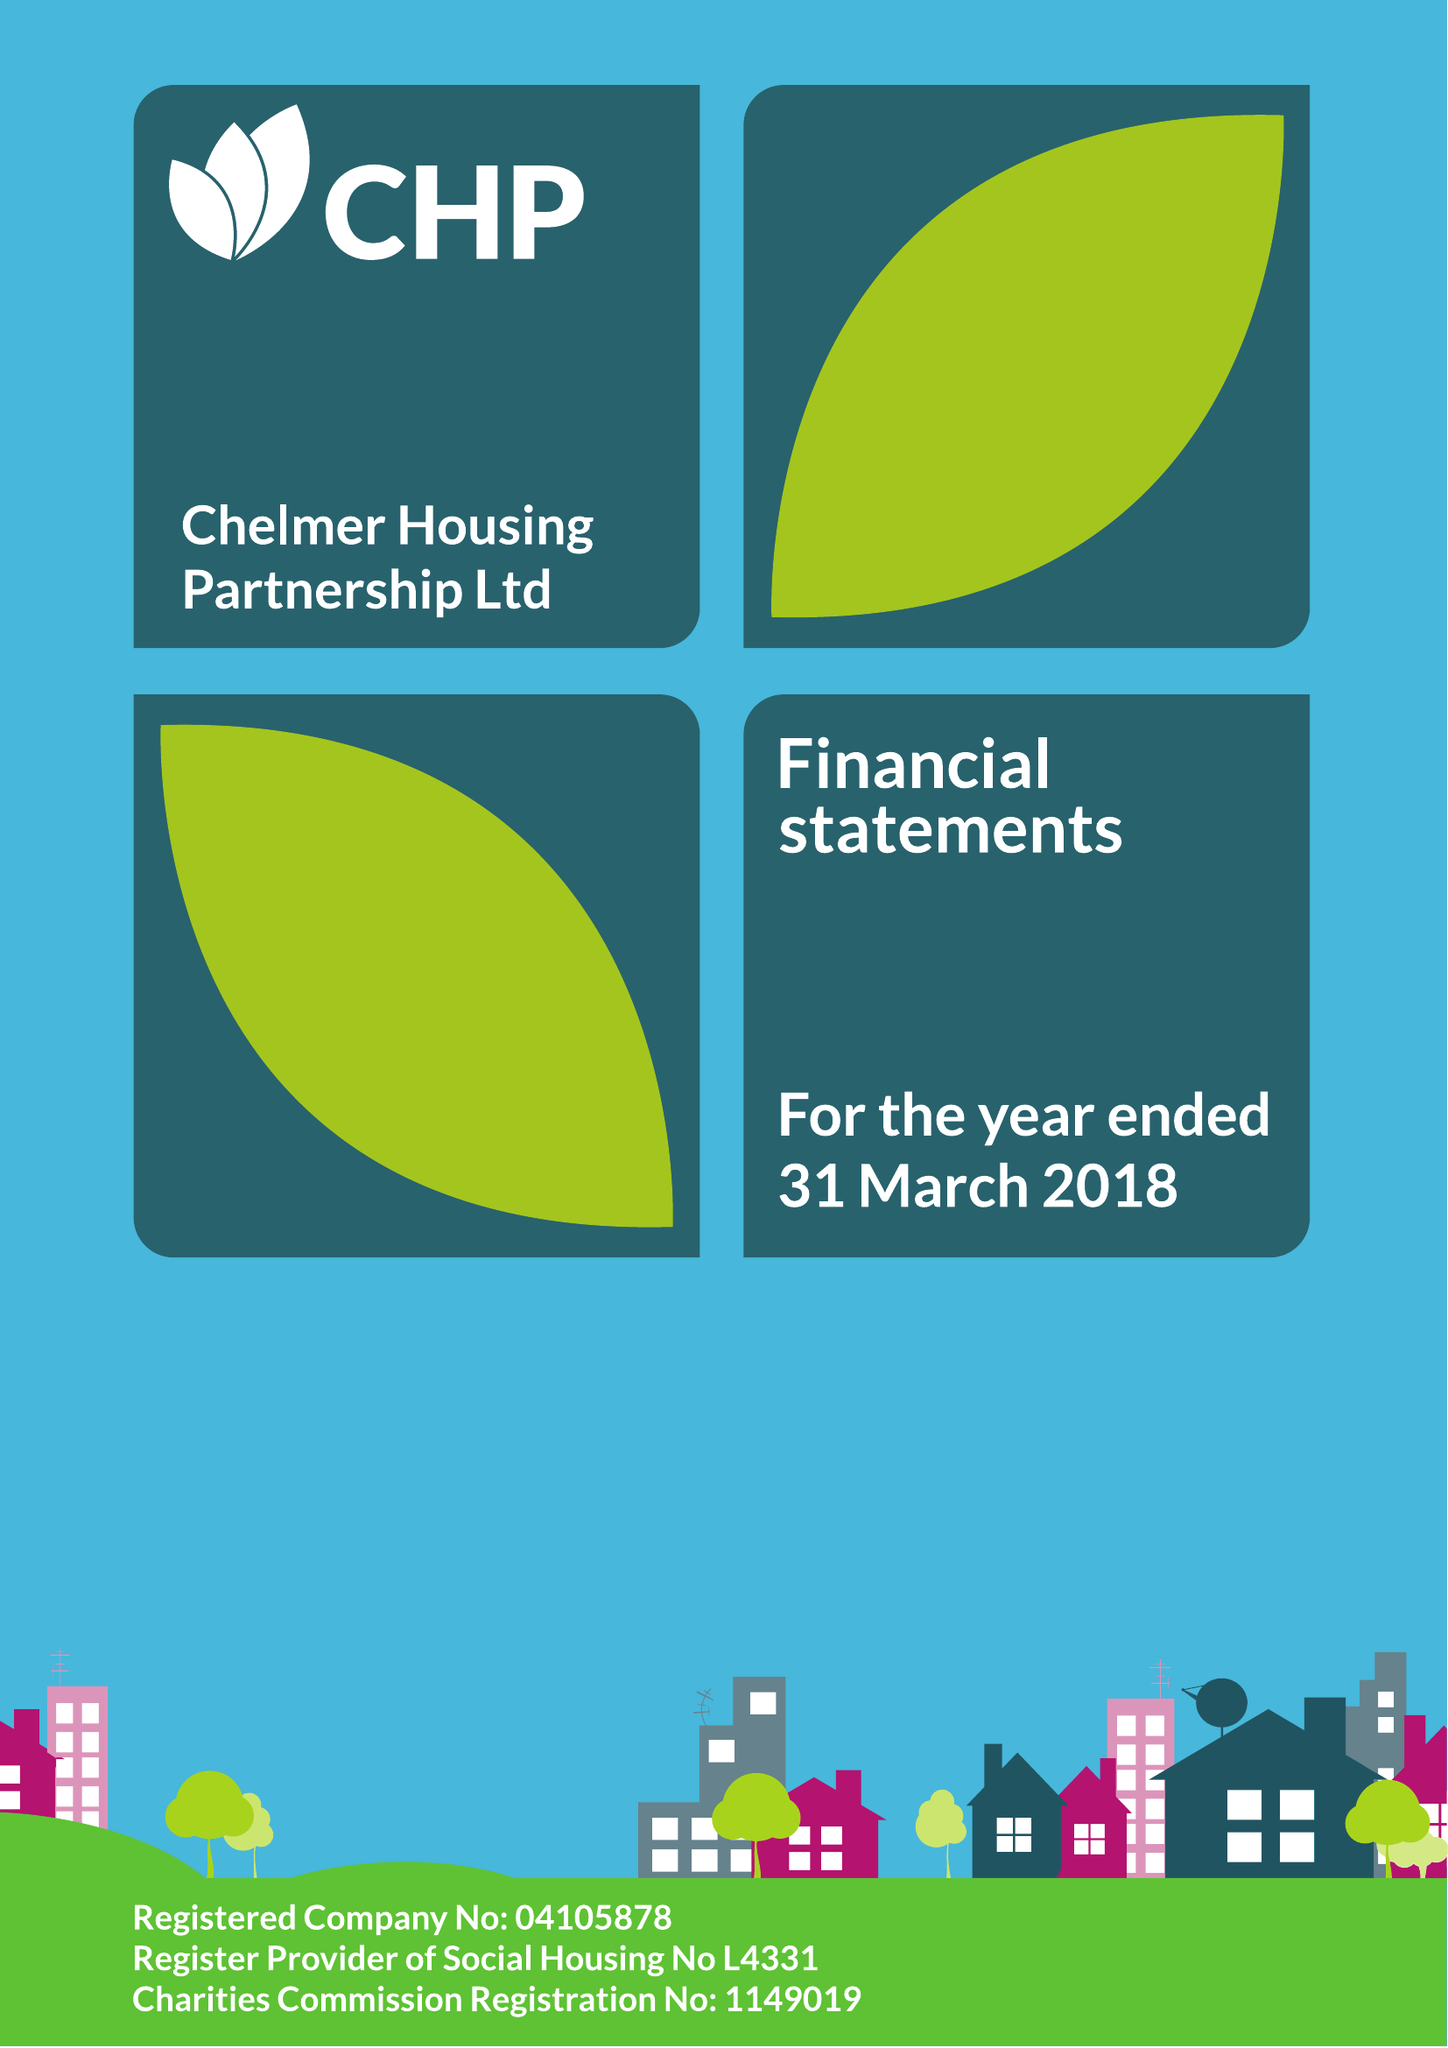What is the value for the charity_name?
Answer the question using a single word or phrase. Chelmer Housing Partnership Ltd. 